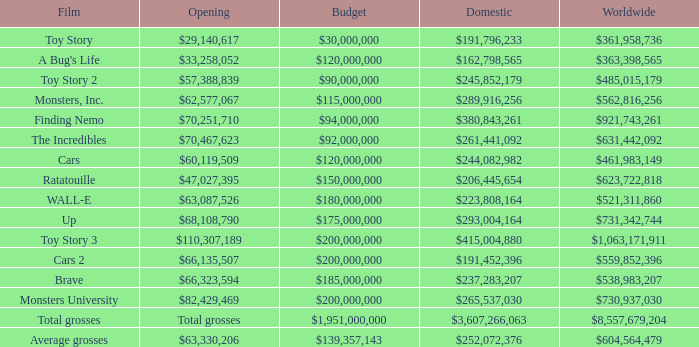WHAT IS THE BUDGET WHEN THE WORLDWIDE BOX OFFICE IS $363,398,565? $120,000,000. 